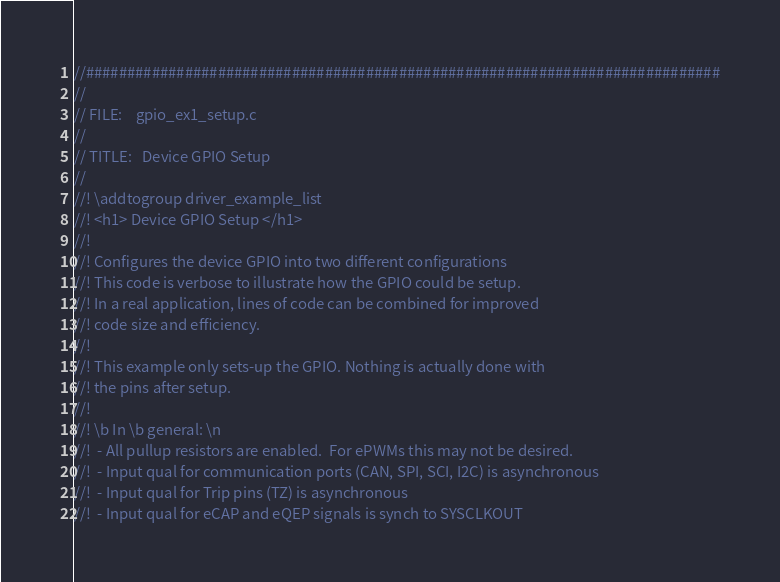<code> <loc_0><loc_0><loc_500><loc_500><_C_>//#############################################################################
//
// FILE:    gpio_ex1_setup.c
//
// TITLE:   Device GPIO Setup
//
//! \addtogroup driver_example_list
//! <h1> Device GPIO Setup </h1>
//!
//! Configures the device GPIO into two different configurations
//! This code is verbose to illustrate how the GPIO could be setup.
//! In a real application, lines of code can be combined for improved
//! code size and efficiency.
//!
//! This example only sets-up the GPIO. Nothing is actually done with
//! the pins after setup.
//!
//! \b In \b general: \n
//!  - All pullup resistors are enabled.  For ePWMs this may not be desired.
//!  - Input qual for communication ports (CAN, SPI, SCI, I2C) is asynchronous
//!  - Input qual for Trip pins (TZ) is asynchronous
//!  - Input qual for eCAP and eQEP signals is synch to SYSCLKOUT</code> 